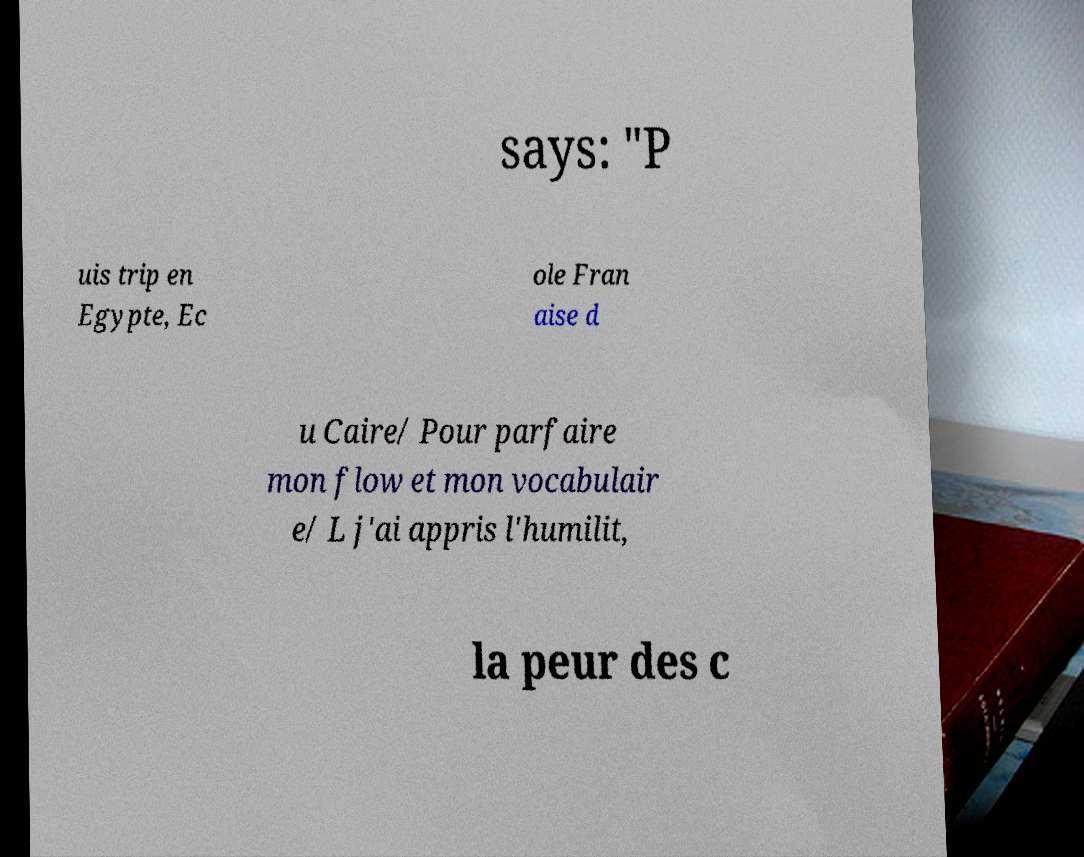What messages or text are displayed in this image? I need them in a readable, typed format. says: "P uis trip en Egypte, Ec ole Fran aise d u Caire/ Pour parfaire mon flow et mon vocabulair e/ L j'ai appris l'humilit, la peur des c 